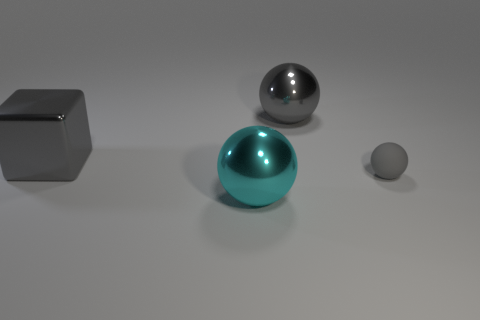Is there anything else that has the same size as the matte sphere?
Provide a short and direct response. No. Are there any other things that are made of the same material as the small object?
Give a very brief answer. No. Does the large block have the same color as the rubber object?
Provide a short and direct response. Yes. Is the color of the large ball behind the small matte thing the same as the rubber thing?
Your answer should be very brief. Yes. What shape is the gray thing that is in front of the gray metallic ball and to the right of the cyan metallic ball?
Offer a terse response. Sphere. Are there any small matte things of the same color as the tiny rubber ball?
Give a very brief answer. No. What color is the metal sphere that is behind the large gray thing that is left of the cyan metallic sphere?
Make the answer very short. Gray. There is a gray sphere behind the gray thing to the left of the large sphere that is behind the cyan shiny ball; what size is it?
Provide a succinct answer. Large. Does the cube have the same material as the gray ball in front of the big block?
Keep it short and to the point. No. There is a cyan thing that is made of the same material as the big gray sphere; what is its size?
Offer a terse response. Large. 